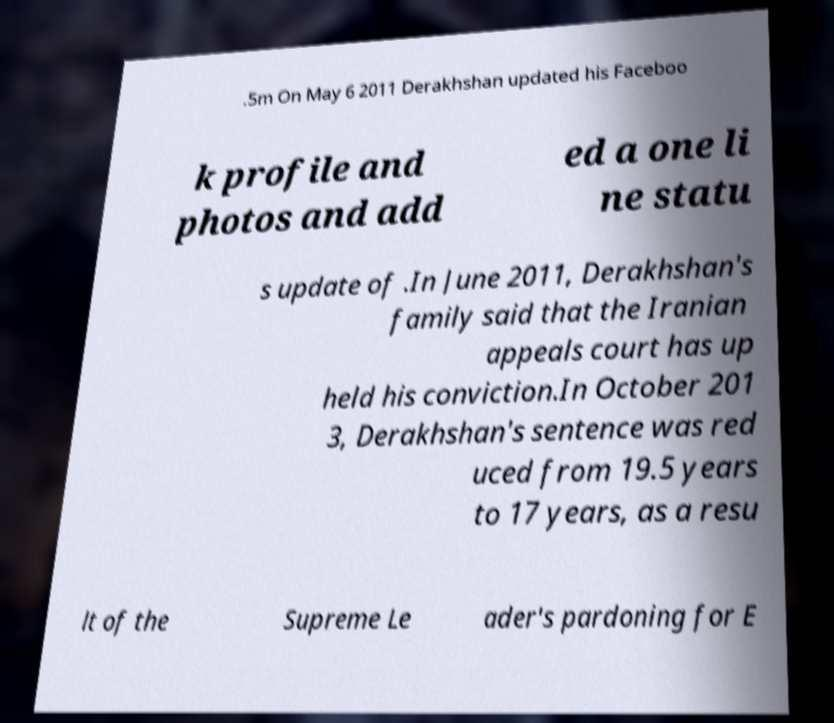Can you accurately transcribe the text from the provided image for me? .5m On May 6 2011 Derakhshan updated his Faceboo k profile and photos and add ed a one li ne statu s update of .In June 2011, Derakhshan's family said that the Iranian appeals court has up held his conviction.In October 201 3, Derakhshan's sentence was red uced from 19.5 years to 17 years, as a resu lt of the Supreme Le ader's pardoning for E 